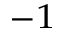Convert formula to latex. <formula><loc_0><loc_0><loc_500><loc_500>^ { - 1 }</formula> 